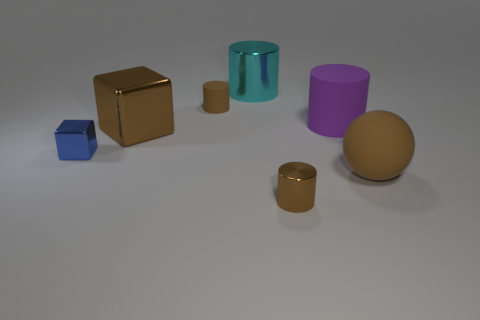Subtract all cyan cylinders. How many cylinders are left? 3 Subtract all brown cylinders. How many cylinders are left? 2 Subtract all cylinders. How many objects are left? 3 Add 2 large rubber cylinders. How many objects exist? 9 Subtract 1 blocks. How many blocks are left? 1 Subtract all blue cubes. Subtract all blue balls. How many cubes are left? 1 Subtract all yellow cylinders. How many green cubes are left? 0 Subtract all cyan things. Subtract all brown matte cylinders. How many objects are left? 5 Add 3 small brown matte cylinders. How many small brown matte cylinders are left? 4 Add 1 metallic spheres. How many metallic spheres exist? 1 